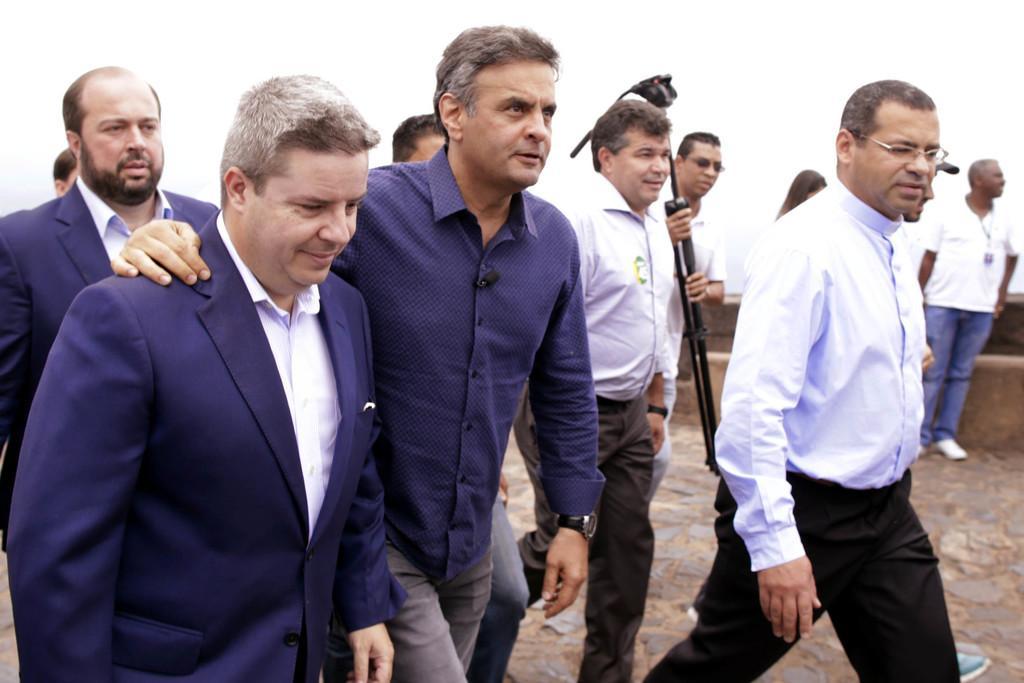Can you describe this image briefly? In this image there are some people who are walking and one person is holding sticks and walking, at the bottom there is a walkway. In the background there is a wall. 